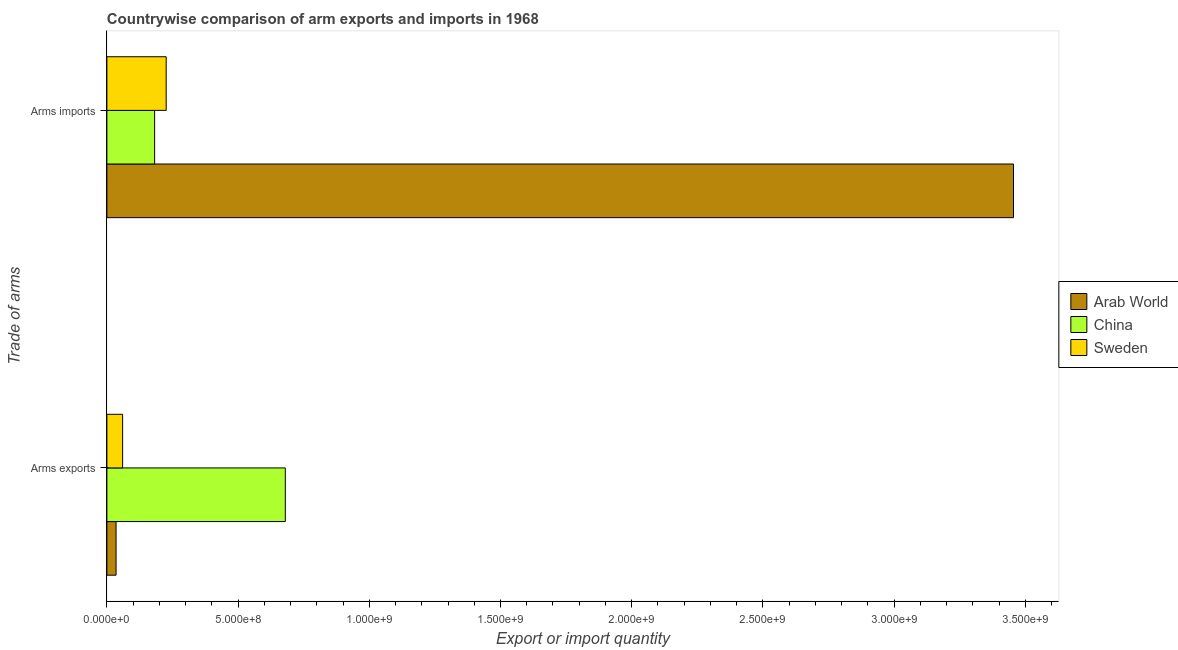How many different coloured bars are there?
Your answer should be compact. 3. Are the number of bars per tick equal to the number of legend labels?
Make the answer very short. Yes. How many bars are there on the 2nd tick from the top?
Give a very brief answer. 3. What is the label of the 2nd group of bars from the top?
Your response must be concise. Arms exports. What is the arms imports in China?
Provide a short and direct response. 1.82e+08. Across all countries, what is the maximum arms imports?
Provide a short and direct response. 3.46e+09. Across all countries, what is the minimum arms imports?
Your response must be concise. 1.82e+08. In which country was the arms imports maximum?
Offer a terse response. Arab World. In which country was the arms exports minimum?
Provide a short and direct response. Arab World. What is the total arms imports in the graph?
Your answer should be very brief. 3.86e+09. What is the difference between the arms imports in Arab World and that in China?
Your answer should be compact. 3.27e+09. What is the difference between the arms exports in China and the arms imports in Sweden?
Your response must be concise. 4.54e+08. What is the average arms exports per country?
Offer a very short reply. 2.58e+08. What is the difference between the arms imports and arms exports in Sweden?
Make the answer very short. 1.66e+08. In how many countries, is the arms exports greater than 1500000000 ?
Provide a short and direct response. 0. What is the ratio of the arms imports in Arab World to that in China?
Offer a terse response. 18.98. What does the 1st bar from the bottom in Arms imports represents?
Your response must be concise. Arab World. How many bars are there?
Ensure brevity in your answer.  6. How many countries are there in the graph?
Your answer should be very brief. 3. How many legend labels are there?
Make the answer very short. 3. What is the title of the graph?
Ensure brevity in your answer.  Countrywise comparison of arm exports and imports in 1968. What is the label or title of the X-axis?
Your response must be concise. Export or import quantity. What is the label or title of the Y-axis?
Provide a short and direct response. Trade of arms. What is the Export or import quantity of Arab World in Arms exports?
Give a very brief answer. 3.50e+07. What is the Export or import quantity of China in Arms exports?
Ensure brevity in your answer.  6.80e+08. What is the Export or import quantity in Sweden in Arms exports?
Give a very brief answer. 6.00e+07. What is the Export or import quantity of Arab World in Arms imports?
Your response must be concise. 3.46e+09. What is the Export or import quantity of China in Arms imports?
Provide a short and direct response. 1.82e+08. What is the Export or import quantity of Sweden in Arms imports?
Provide a succinct answer. 2.26e+08. Across all Trade of arms, what is the maximum Export or import quantity in Arab World?
Make the answer very short. 3.46e+09. Across all Trade of arms, what is the maximum Export or import quantity in China?
Provide a short and direct response. 6.80e+08. Across all Trade of arms, what is the maximum Export or import quantity in Sweden?
Your answer should be compact. 2.26e+08. Across all Trade of arms, what is the minimum Export or import quantity in Arab World?
Your answer should be very brief. 3.50e+07. Across all Trade of arms, what is the minimum Export or import quantity of China?
Provide a short and direct response. 1.82e+08. Across all Trade of arms, what is the minimum Export or import quantity of Sweden?
Your response must be concise. 6.00e+07. What is the total Export or import quantity in Arab World in the graph?
Keep it short and to the point. 3.49e+09. What is the total Export or import quantity of China in the graph?
Give a very brief answer. 8.62e+08. What is the total Export or import quantity in Sweden in the graph?
Give a very brief answer. 2.86e+08. What is the difference between the Export or import quantity in Arab World in Arms exports and that in Arms imports?
Give a very brief answer. -3.42e+09. What is the difference between the Export or import quantity of China in Arms exports and that in Arms imports?
Provide a succinct answer. 4.98e+08. What is the difference between the Export or import quantity of Sweden in Arms exports and that in Arms imports?
Make the answer very short. -1.66e+08. What is the difference between the Export or import quantity of Arab World in Arms exports and the Export or import quantity of China in Arms imports?
Give a very brief answer. -1.47e+08. What is the difference between the Export or import quantity in Arab World in Arms exports and the Export or import quantity in Sweden in Arms imports?
Offer a very short reply. -1.91e+08. What is the difference between the Export or import quantity of China in Arms exports and the Export or import quantity of Sweden in Arms imports?
Your answer should be compact. 4.54e+08. What is the average Export or import quantity in Arab World per Trade of arms?
Your answer should be compact. 1.74e+09. What is the average Export or import quantity in China per Trade of arms?
Offer a very short reply. 4.31e+08. What is the average Export or import quantity in Sweden per Trade of arms?
Provide a succinct answer. 1.43e+08. What is the difference between the Export or import quantity in Arab World and Export or import quantity in China in Arms exports?
Offer a very short reply. -6.45e+08. What is the difference between the Export or import quantity in Arab World and Export or import quantity in Sweden in Arms exports?
Your answer should be very brief. -2.50e+07. What is the difference between the Export or import quantity of China and Export or import quantity of Sweden in Arms exports?
Your response must be concise. 6.20e+08. What is the difference between the Export or import quantity of Arab World and Export or import quantity of China in Arms imports?
Your answer should be very brief. 3.27e+09. What is the difference between the Export or import quantity of Arab World and Export or import quantity of Sweden in Arms imports?
Keep it short and to the point. 3.23e+09. What is the difference between the Export or import quantity in China and Export or import quantity in Sweden in Arms imports?
Your answer should be very brief. -4.40e+07. What is the ratio of the Export or import quantity in Arab World in Arms exports to that in Arms imports?
Your answer should be very brief. 0.01. What is the ratio of the Export or import quantity of China in Arms exports to that in Arms imports?
Keep it short and to the point. 3.74. What is the ratio of the Export or import quantity in Sweden in Arms exports to that in Arms imports?
Your answer should be very brief. 0.27. What is the difference between the highest and the second highest Export or import quantity of Arab World?
Your answer should be compact. 3.42e+09. What is the difference between the highest and the second highest Export or import quantity in China?
Provide a short and direct response. 4.98e+08. What is the difference between the highest and the second highest Export or import quantity of Sweden?
Offer a very short reply. 1.66e+08. What is the difference between the highest and the lowest Export or import quantity of Arab World?
Make the answer very short. 3.42e+09. What is the difference between the highest and the lowest Export or import quantity in China?
Your answer should be compact. 4.98e+08. What is the difference between the highest and the lowest Export or import quantity in Sweden?
Offer a terse response. 1.66e+08. 